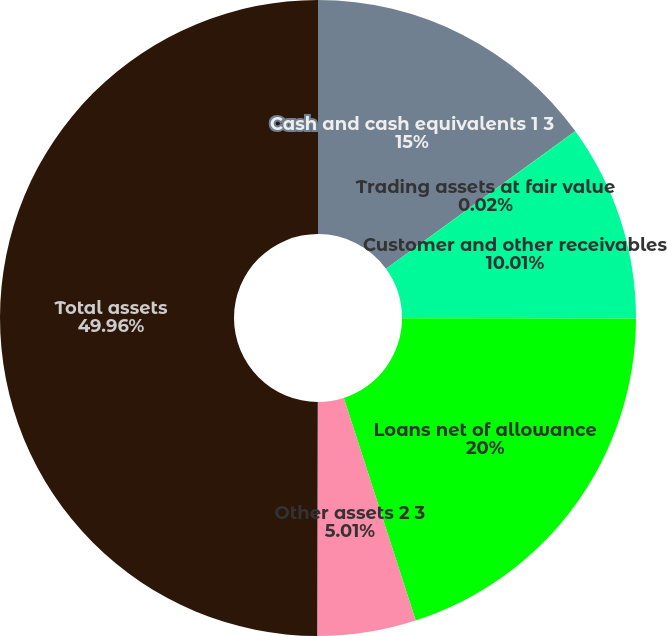Convert chart to OTSL. <chart><loc_0><loc_0><loc_500><loc_500><pie_chart><fcel>Cash and cash equivalents 1 3<fcel>Trading assets at fair value<fcel>Customer and other receivables<fcel>Loans net of allowance<fcel>Other assets 2 3<fcel>Total assets<nl><fcel>15.0%<fcel>0.02%<fcel>10.01%<fcel>20.0%<fcel>5.01%<fcel>49.96%<nl></chart> 